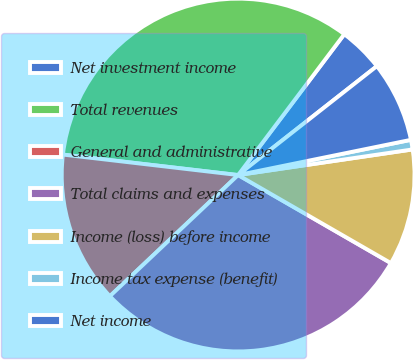<chart> <loc_0><loc_0><loc_500><loc_500><pie_chart><fcel>Net investment income<fcel>Total revenues<fcel>General and administrative<fcel>Total claims and expenses<fcel>Income (loss) before income<fcel>Income tax expense (benefit)<fcel>Net income<nl><fcel>4.13%<fcel>33.43%<fcel>13.9%<fcel>29.63%<fcel>10.64%<fcel>0.88%<fcel>7.39%<nl></chart> 